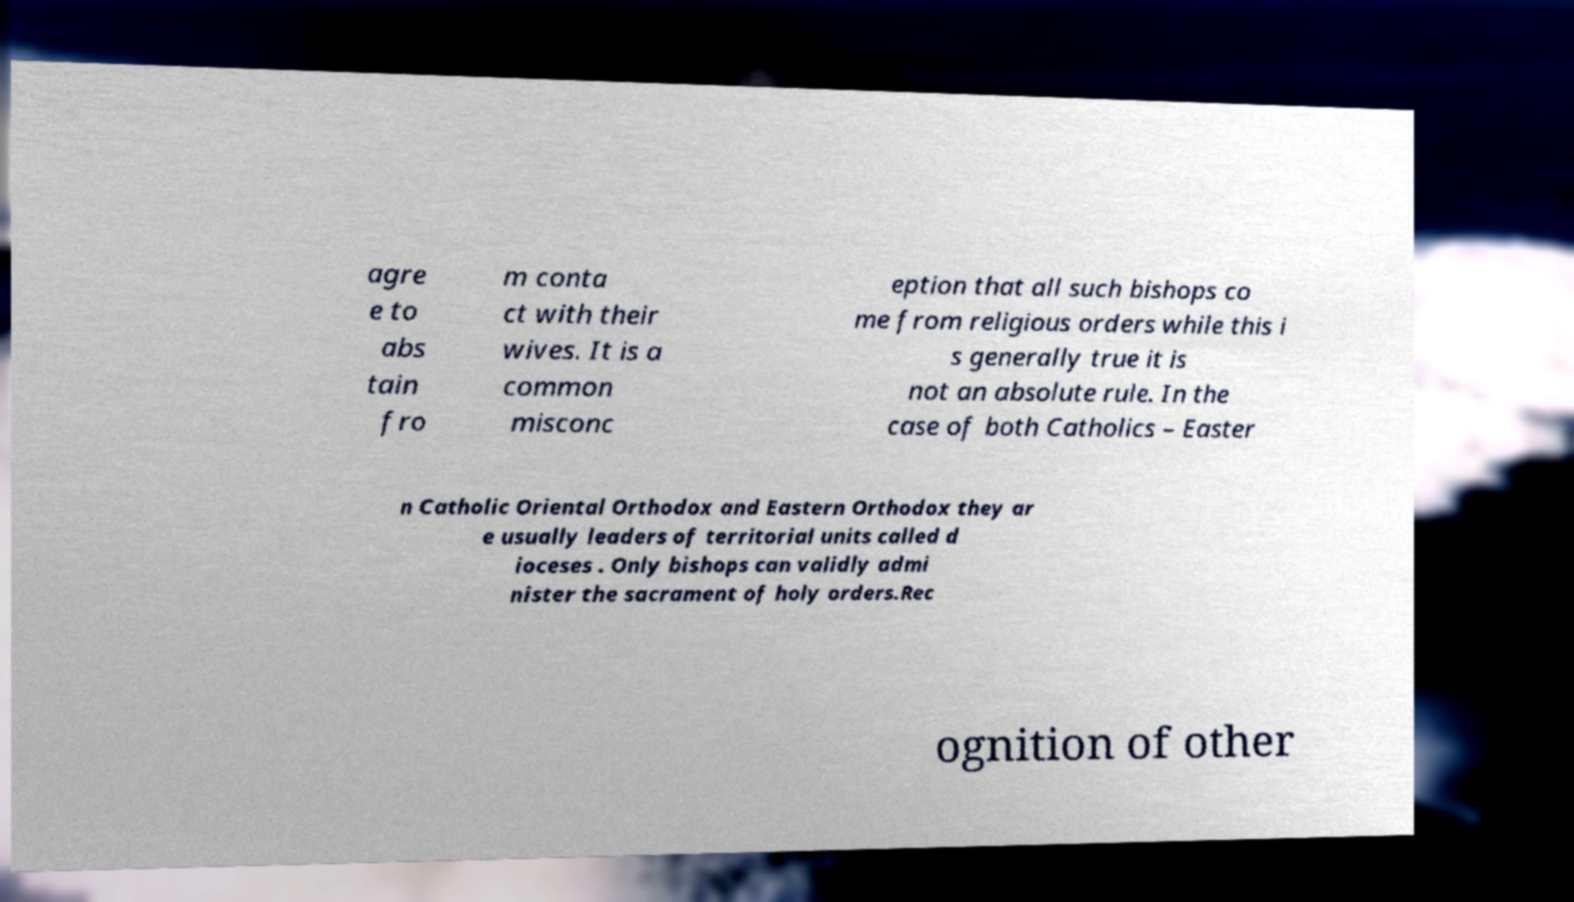Could you extract and type out the text from this image? agre e to abs tain fro m conta ct with their wives. It is a common misconc eption that all such bishops co me from religious orders while this i s generally true it is not an absolute rule. In the case of both Catholics – Easter n Catholic Oriental Orthodox and Eastern Orthodox they ar e usually leaders of territorial units called d ioceses . Only bishops can validly admi nister the sacrament of holy orders.Rec ognition of other 